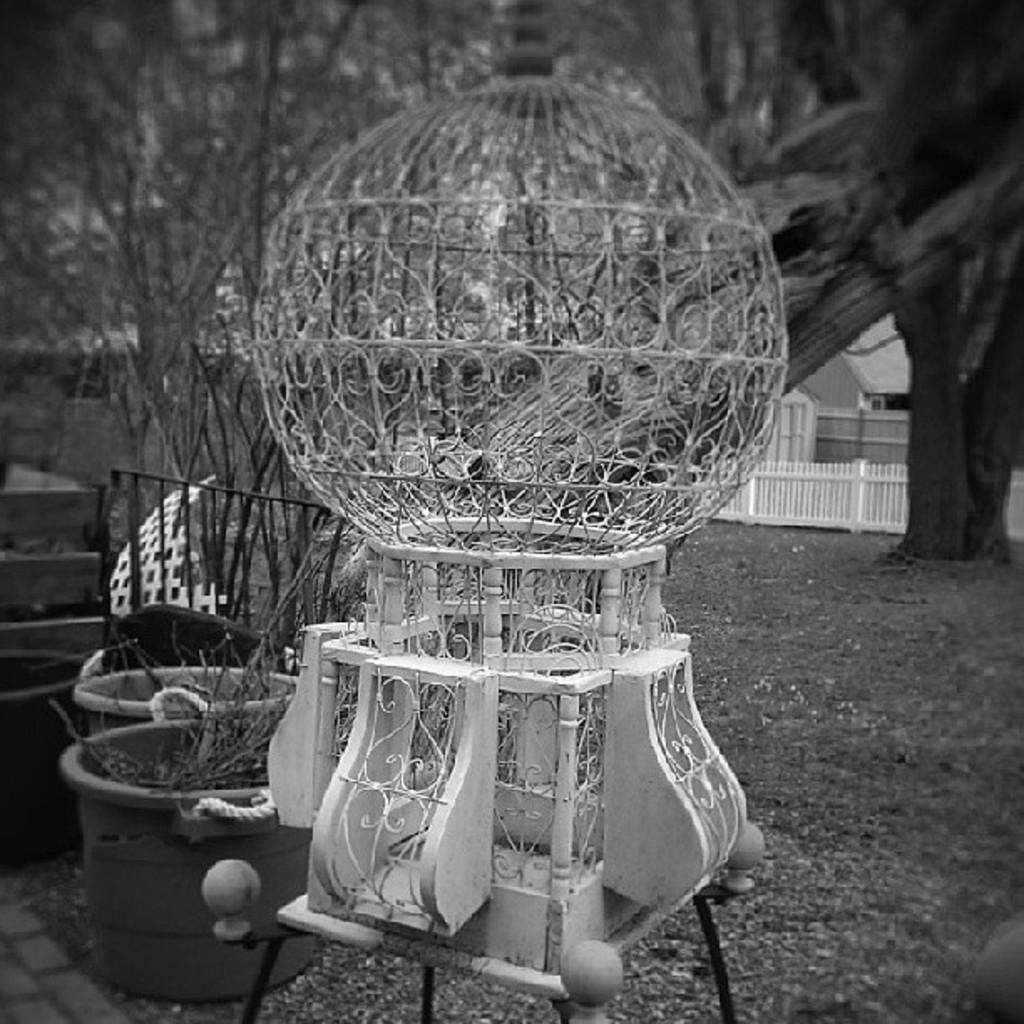What type of vegetation can be seen in the image? There are trees and plants in the image. What type of barrier is present in the image? There is fencing in the image. What is the color of the object on the table in the image? The object on the table is white. Can you hear the alarm going off in the image? There is no alarm present in the image, so it cannot be heard. 